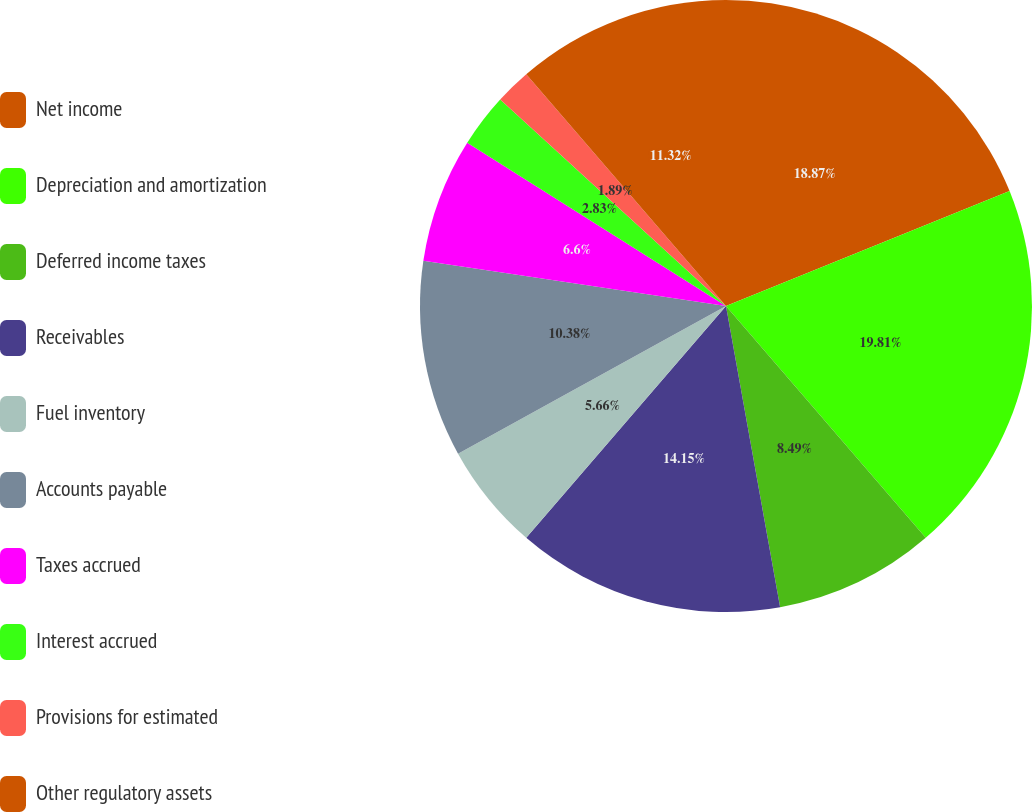<chart> <loc_0><loc_0><loc_500><loc_500><pie_chart><fcel>Net income<fcel>Depreciation and amortization<fcel>Deferred income taxes<fcel>Receivables<fcel>Fuel inventory<fcel>Accounts payable<fcel>Taxes accrued<fcel>Interest accrued<fcel>Provisions for estimated<fcel>Other regulatory assets<nl><fcel>18.87%<fcel>19.81%<fcel>8.49%<fcel>14.15%<fcel>5.66%<fcel>10.38%<fcel>6.6%<fcel>2.83%<fcel>1.89%<fcel>11.32%<nl></chart> 